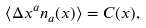<formula> <loc_0><loc_0><loc_500><loc_500>\langle \Delta x ^ { a } n _ { a } ( x ) \rangle = C ( x ) ,</formula> 